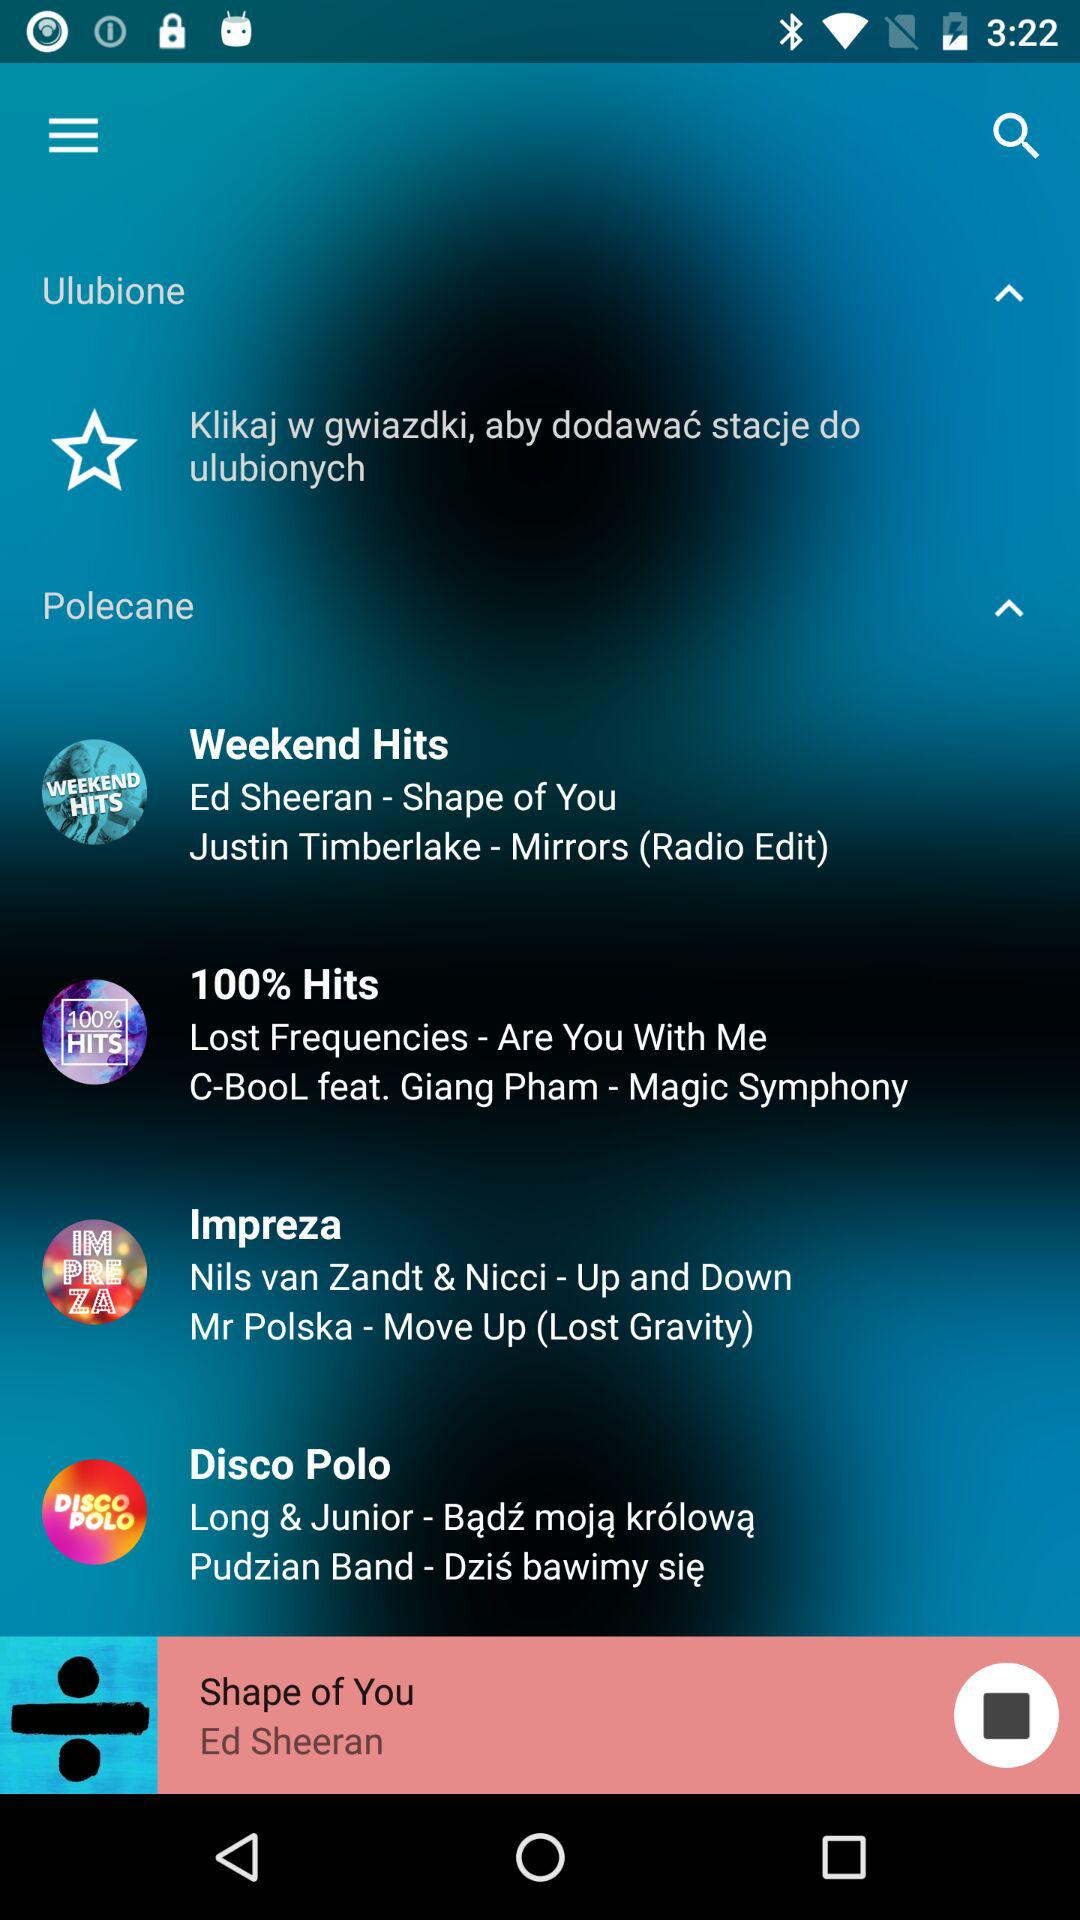What song is playing? The playing song is "Shape of You". 